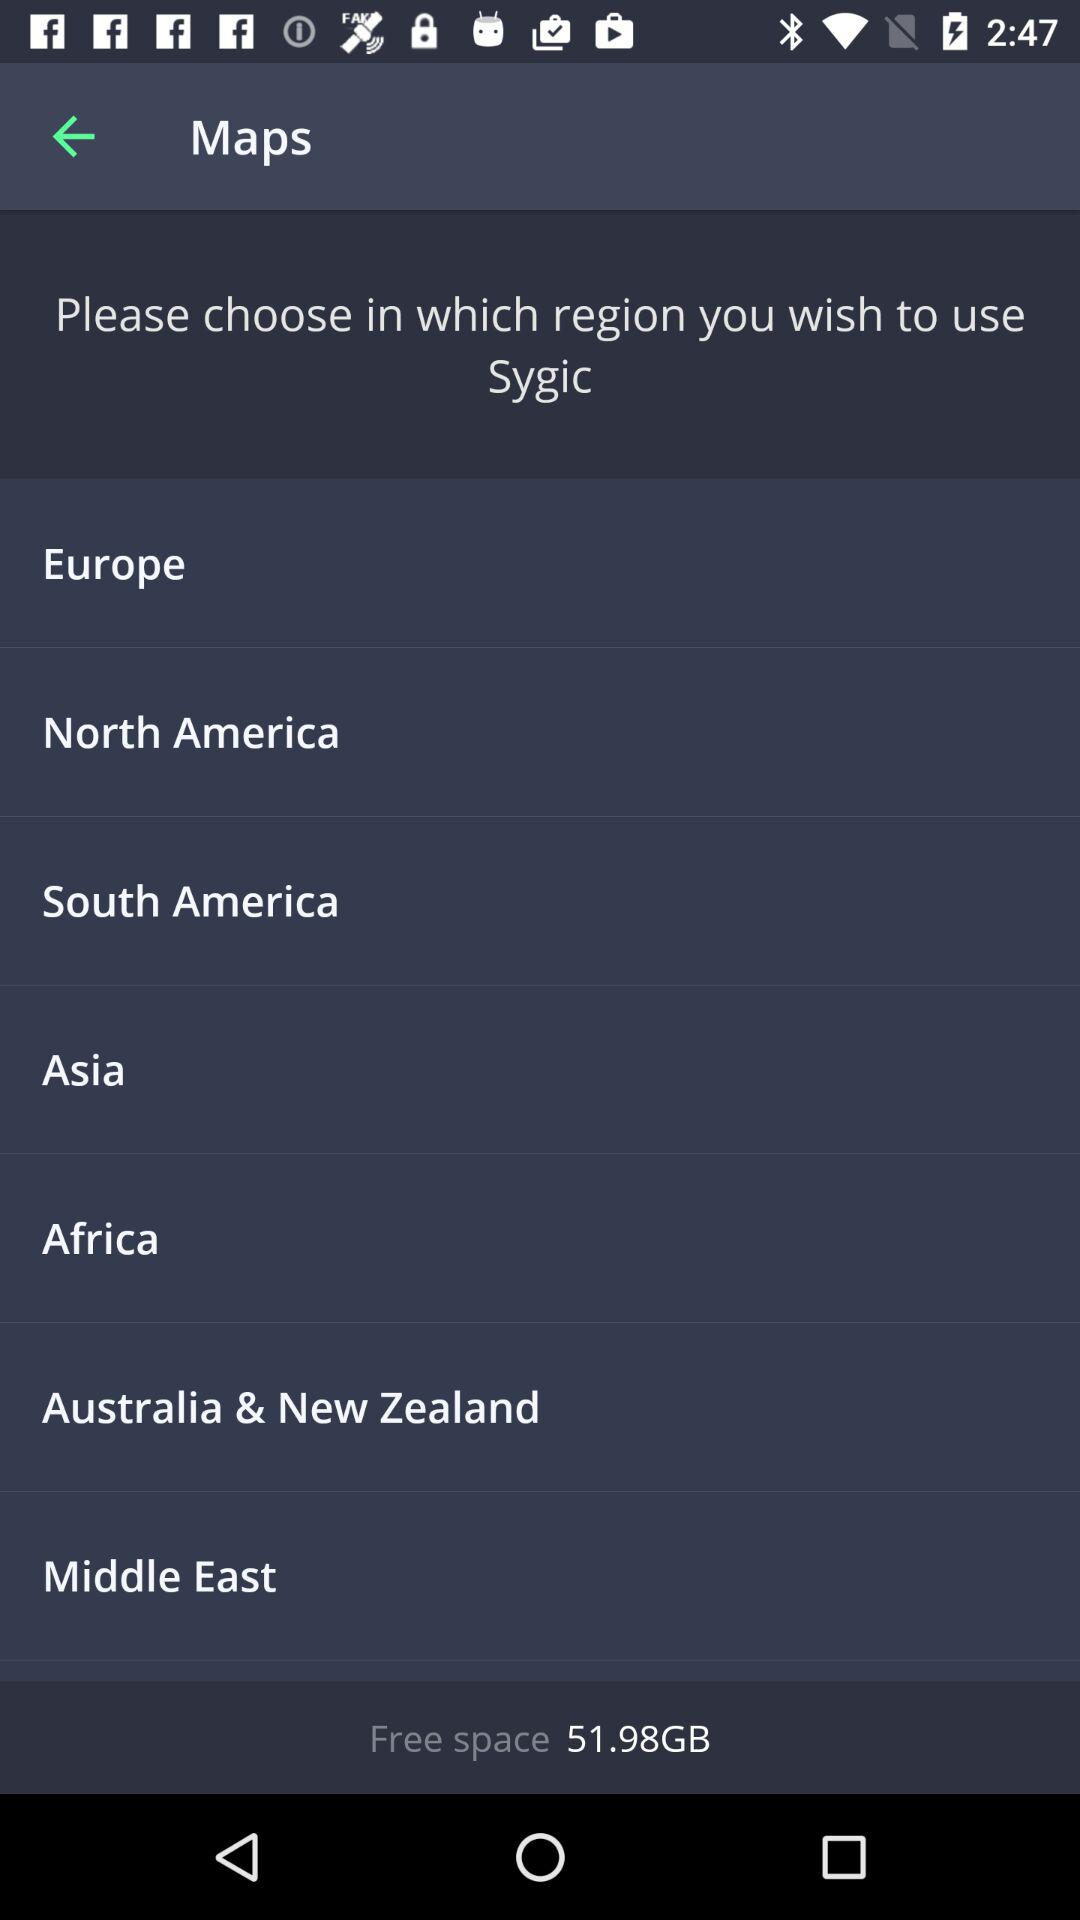How much free space is available on the device? 51.98GB 